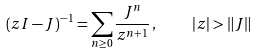Convert formula to latex. <formula><loc_0><loc_0><loc_500><loc_500>( z I - J ) ^ { - 1 } = \sum _ { n \geq 0 } \frac { J ^ { n } } { z ^ { n + 1 } } \, , \quad | z | > \| J \|</formula> 